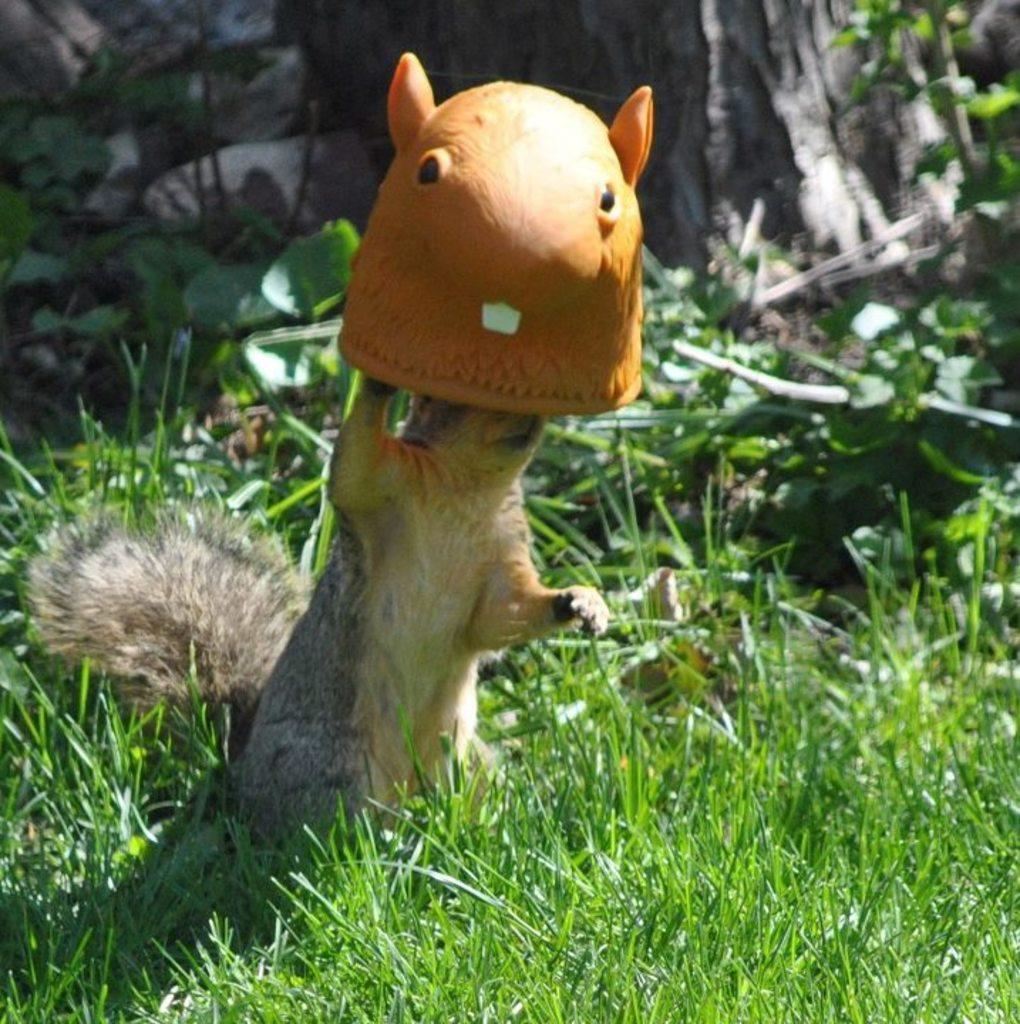What type of animal can be seen in the image? There is a squirrel in the image. What is the squirrel wearing? The squirrel is wearing a mask. What is the ground covered with in the image? There is grass on the ground in the image. What type of vegetation is visible in the image? There are plants visible in the image. What type of fan can be seen in the image? There is no fan present in the image. How many drops of water are visible on the squirrel's mask? There are no drops of water visible on the squirrel's mask; it is wearing a mask, but there is no mention of water in the image. 